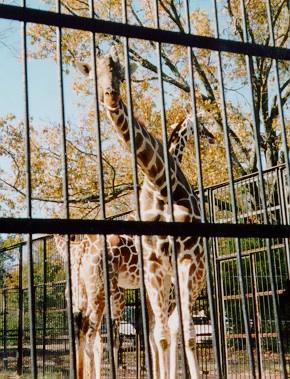Are the leaves starting to die on the trees?
Keep it brief. Yes. Can the giraffe look over the fence?
Write a very short answer. Yes. Are there a lot of small birds?
Write a very short answer. No. How many giraffes are there?
Quick response, please. 2. 